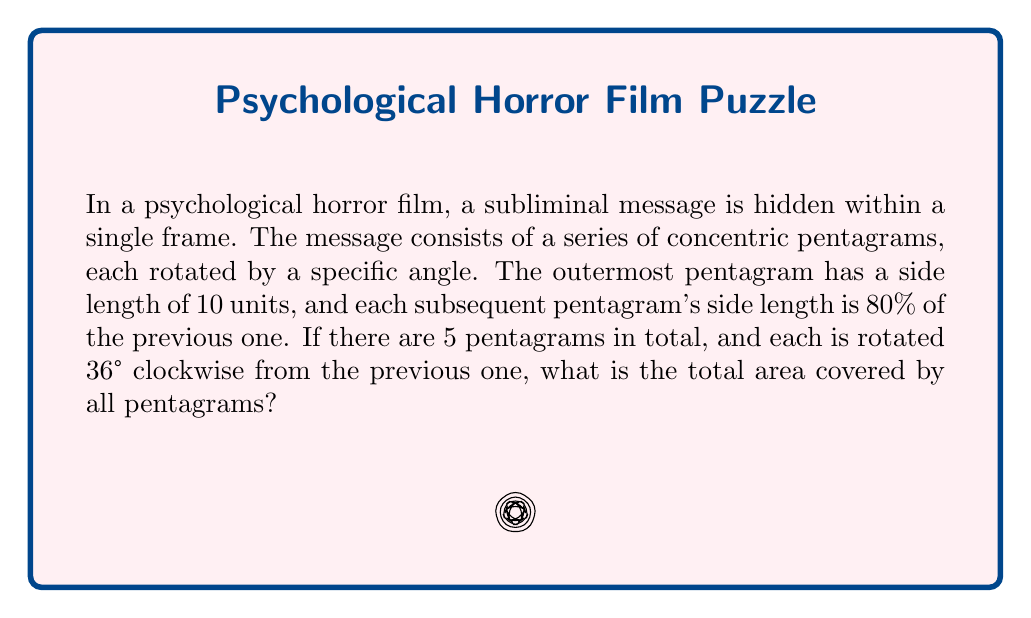Teach me how to tackle this problem. Let's approach this step-by-step:

1) First, we need to calculate the area of a single pentagram. The area of a regular pentagon with side length $s$ is given by:

   $$A = \frac{1}{4}\sqrt{25+10\sqrt{5}}s^2$$

2) For a pentagram, we need to subtract the area of the inner pentagon. The ratio of the side length of the inner pentagon to the outer pentagon in a pentagram is:

   $$r = \frac{\sqrt{5}-1}{2} \approx 0.618$$

3) So, the area of a pentagram with outer side length $s$ is:

   $$A_{pentagram} = \frac{1}{4}\sqrt{25+10\sqrt{5}}s^2 - \frac{1}{4}\sqrt{25+10\sqrt{5}}(rs)^2$$

4) Now, let's calculate the areas of our 5 pentagrams:
   - 1st pentagram: $s_1 = 10$
   - 2nd pentagram: $s_2 = 10 * 0.8 = 8$
   - 3rd pentagram: $s_3 = 10 * 0.8^2 = 6.4$
   - 4th pentagram: $s_4 = 10 * 0.8^3 = 5.12$
   - 5th pentagram: $s_5 = 10 * 0.8^4 = 4.096$

5) The total area is the sum of these 5 pentagrams:

   $$A_{total} = \sum_{i=1}^5 \frac{1}{4}\sqrt{25+10\sqrt{5}}(s_i^2 - (rs_i)^2)$$

6) Substituting the values and simplifying:

   $$A_{total} = \frac{1}{4}\sqrt{25+10\sqrt{5}}(100 + 64 + 40.96 + 26.2144 + 16.777216)(1-r^2)$$

7) Calculating this gives us approximately 172.88 square units.
Answer: 172.88 square units 